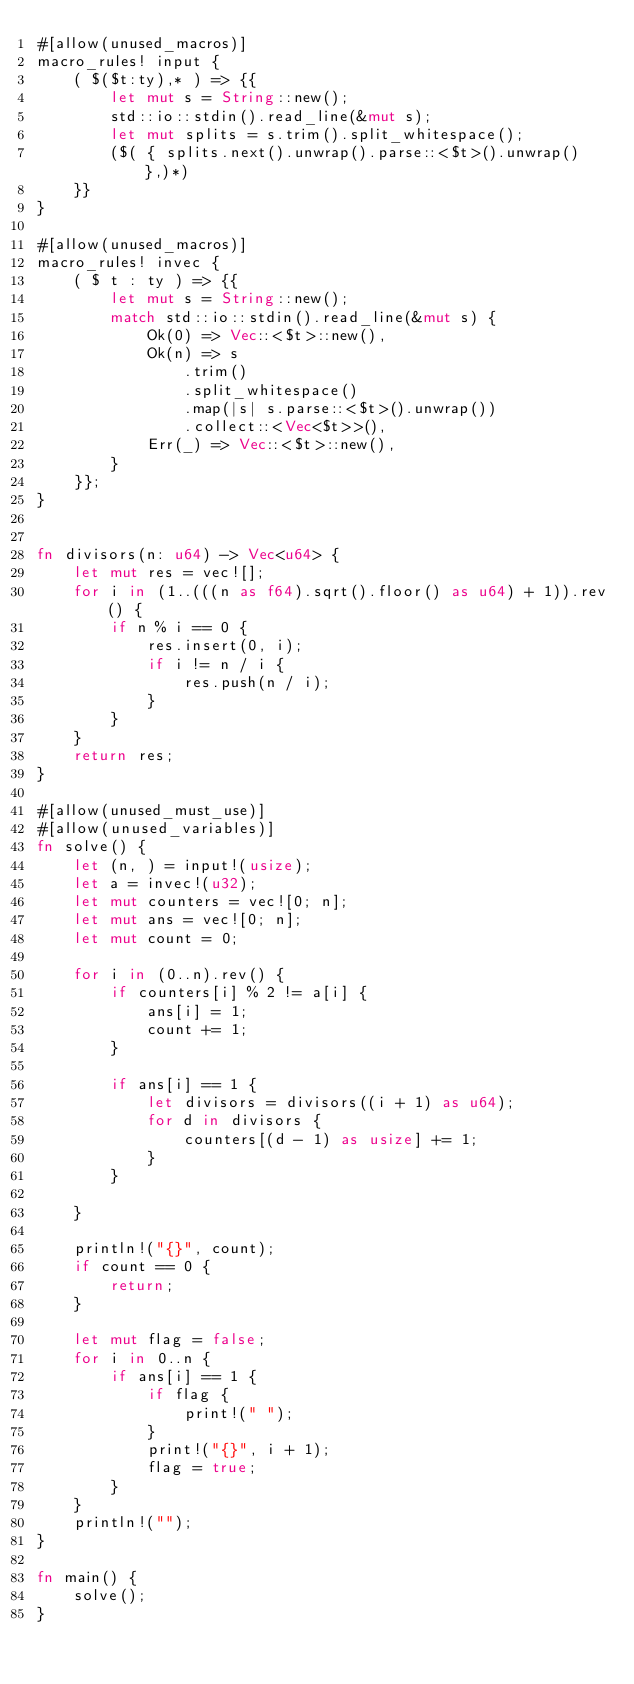<code> <loc_0><loc_0><loc_500><loc_500><_Rust_>#[allow(unused_macros)]
macro_rules! input {
    ( $($t:ty),* ) => {{
        let mut s = String::new();
        std::io::stdin().read_line(&mut s);
        let mut splits = s.trim().split_whitespace();
        ($( { splits.next().unwrap().parse::<$t>().unwrap() },)*)
    }}
}

#[allow(unused_macros)]
macro_rules! invec {
    ( $ t : ty ) => {{
        let mut s = String::new();
        match std::io::stdin().read_line(&mut s) {
            Ok(0) => Vec::<$t>::new(),
            Ok(n) => s
                .trim()
                .split_whitespace()
                .map(|s| s.parse::<$t>().unwrap())
                .collect::<Vec<$t>>(),
            Err(_) => Vec::<$t>::new(),
        }
    }};
}


fn divisors(n: u64) -> Vec<u64> {
    let mut res = vec![];
    for i in (1..(((n as f64).sqrt().floor() as u64) + 1)).rev() {
        if n % i == 0 {
            res.insert(0, i);
            if i != n / i {
                res.push(n / i);
            }
        }
    }
    return res;
}

#[allow(unused_must_use)]
#[allow(unused_variables)]
fn solve() {
    let (n, ) = input!(usize);
    let a = invec!(u32);
    let mut counters = vec![0; n];
    let mut ans = vec![0; n];
    let mut count = 0;
    
    for i in (0..n).rev() {
        if counters[i] % 2 != a[i] {
            ans[i] = 1;
            count += 1;
        }

        if ans[i] == 1 {
            let divisors = divisors((i + 1) as u64);
            for d in divisors {
                counters[(d - 1) as usize] += 1;
            }
        }

    }

    println!("{}", count);
    if count == 0 {
        return;
    }

    let mut flag = false;
    for i in 0..n {
        if ans[i] == 1 {
            if flag {
                print!(" ");
            }
            print!("{}", i + 1);
            flag = true;
        }
    }
    println!("");
}

fn main() {
    solve();
}
</code> 